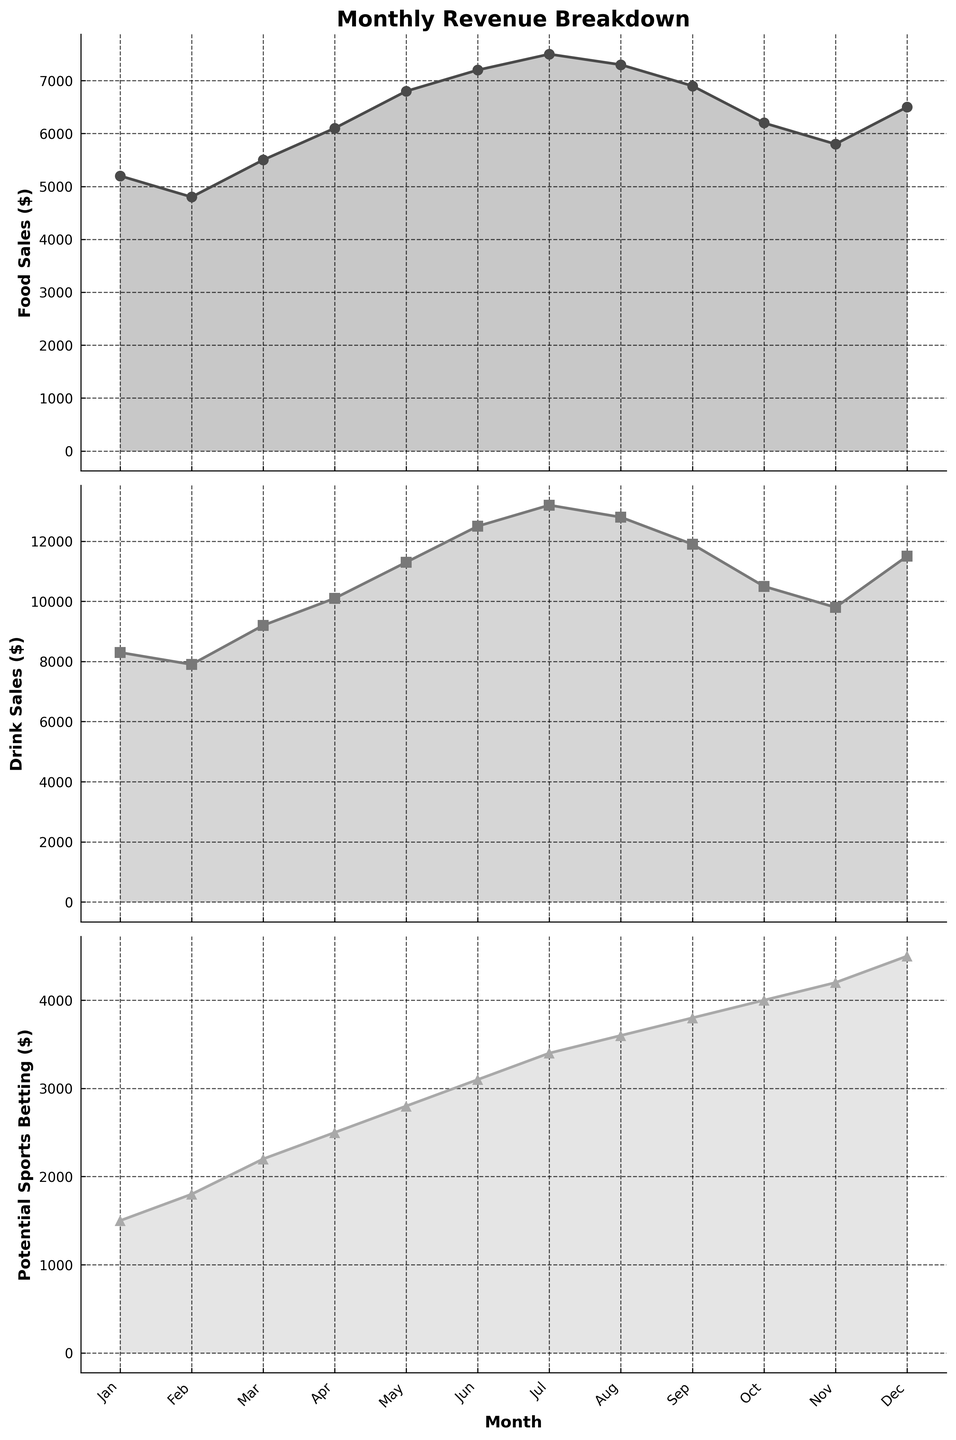What month had the highest food sales? The highest point in the first plot shows us which month. The peak of the food sales line is in July at $7500.
Answer: July In which month did drink sales surpass $12000? In the second plot, look for when the drink sales line crosses the $12000 level. This happens in June, July, and August.
Answer: June, July, August What is the total potential sports betting income for Q1 (Jan-Mar)? Add the first three values in the third plot (January, February, March): 1500 + 1800 + 2200 = 5500.
Answer: 5500 When comparing food sales and drink sales, which month had a greater increase in revenue compared to the previous month? For each month, compare the increase from the previous month in both plots. Notice the steepest positive slope:  
- Food Sales: April (6100-5500=600), May (6800-6100=700), June (7200-6800=400), July (7500-7200=300).
- Drink Sales: April (10100-9200=900), May (11300-10100=1200), June (12500-11300=1200), July (13200-12500=700).
Answer: May for both Which revenue source shows the largest percentage increase from Jan to Dec? Calculate the percentage increase for each source:  
- Food Sales: ((6500 - 5200) / 5200) * 100 ≈ 25%
- Drink Sales: ((11500 - 8300) / 8300) * 100 ≈ 38.55%
- Potential Sports Betting: ((4500 - 1500) / 1500) * 100 = 200%
Answer: Potential Sports Betting By how much did potential sports betting income exceed food sales in November? Subtract November food sales from potential sports betting in the third plot: 4200 - 5800 = -1600
Answer: It did not exceed; food sales were higher by $1600 Which month experienced the least difference between food and drink sales? Find the month where the gap between the two lines in the first and second plots is smallest.  
- Calculate the differences for each month; the smallest difference is in January with (8300-5200=3100).
Answer: January What is the average drink sales across all months? Add all drink sales values and then divide by 12 (total months): (8300+7900+9200+10100+11300+12500+13200+12800+11900+10500+9800+11500)/12 ≈ 10650
Answer: 10650 